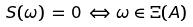<formula> <loc_0><loc_0><loc_500><loc_500>S ( \omega ) \, = \, 0 \, \Leftrightarrow \, \omega \in \Xi ( A )</formula> 